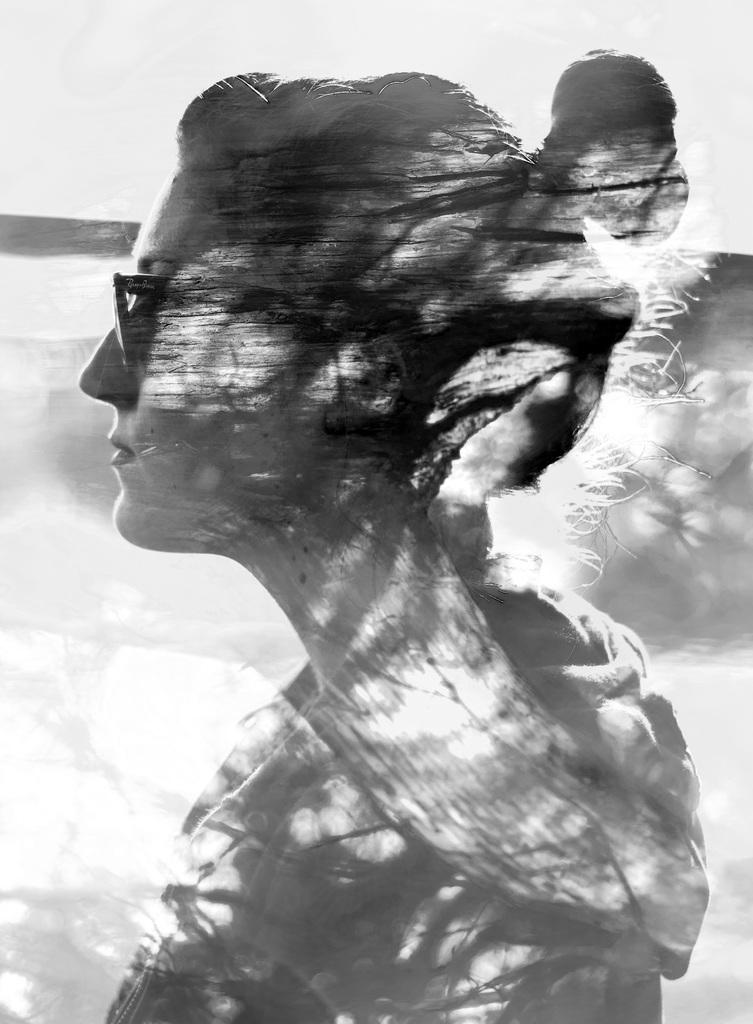What is the color scheme of the image? The image is black and white. Can you describe the person in the image? There is a lady in the image. What accessory is the lady wearing? The lady is wearing glasses. Can you tell me how many goldfish are swimming in the ocean in the image? There is no ocean or goldfish present in the image; it features a black and white image of a lady wearing glasses. 